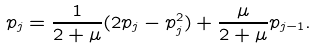Convert formula to latex. <formula><loc_0><loc_0><loc_500><loc_500>p _ { j } = \frac { 1 } { 2 + \mu } ( 2 p _ { j } - p _ { j } ^ { 2 } ) + \frac { \mu } { 2 + \mu } p _ { j - 1 } .</formula> 